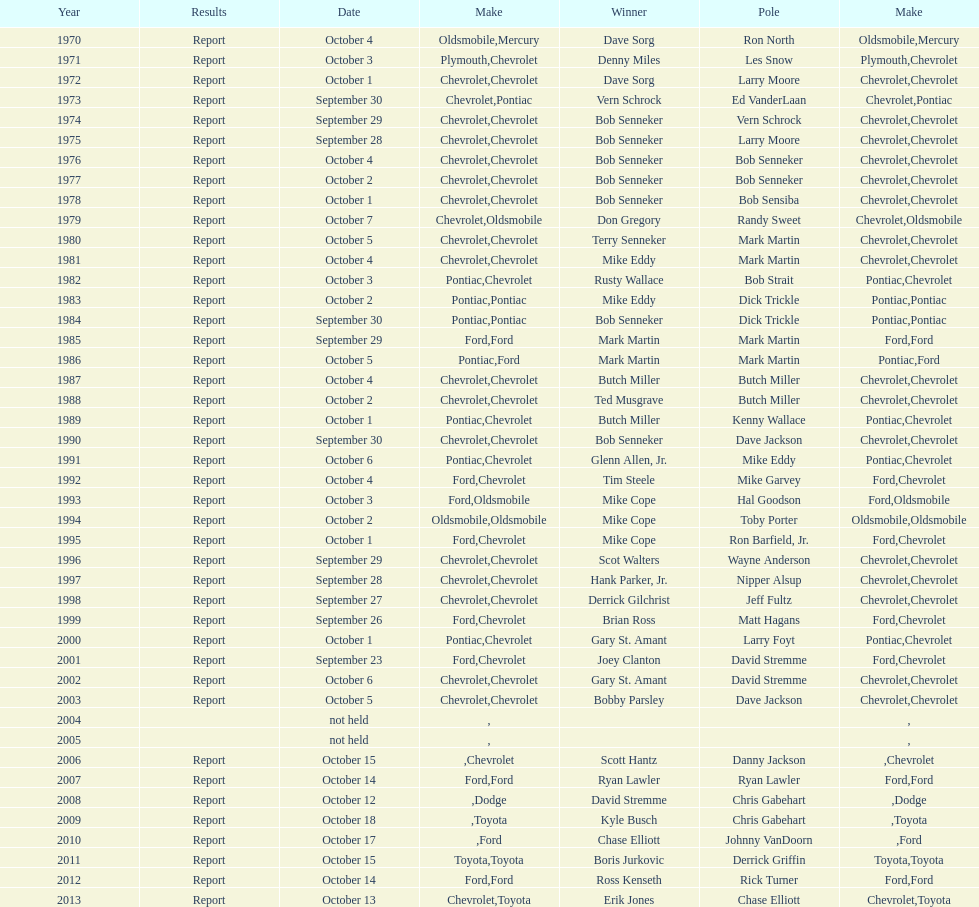Which make was used the least? Mercury. 